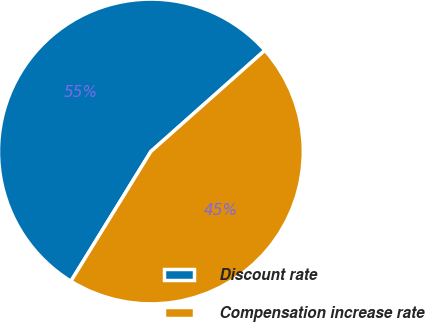Convert chart. <chart><loc_0><loc_0><loc_500><loc_500><pie_chart><fcel>Discount rate<fcel>Compensation increase rate<nl><fcel>54.65%<fcel>45.35%<nl></chart> 